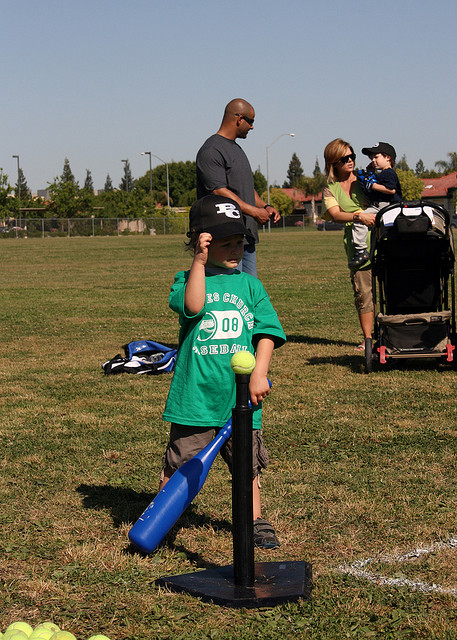<image>What toy character is on the boy's shirt? There is no toy character on the boy's shirt according to the information provided. What toy character is on the boy's shirt? I don't know what toy character is on the boy's shirt. It is not visible in the image. 